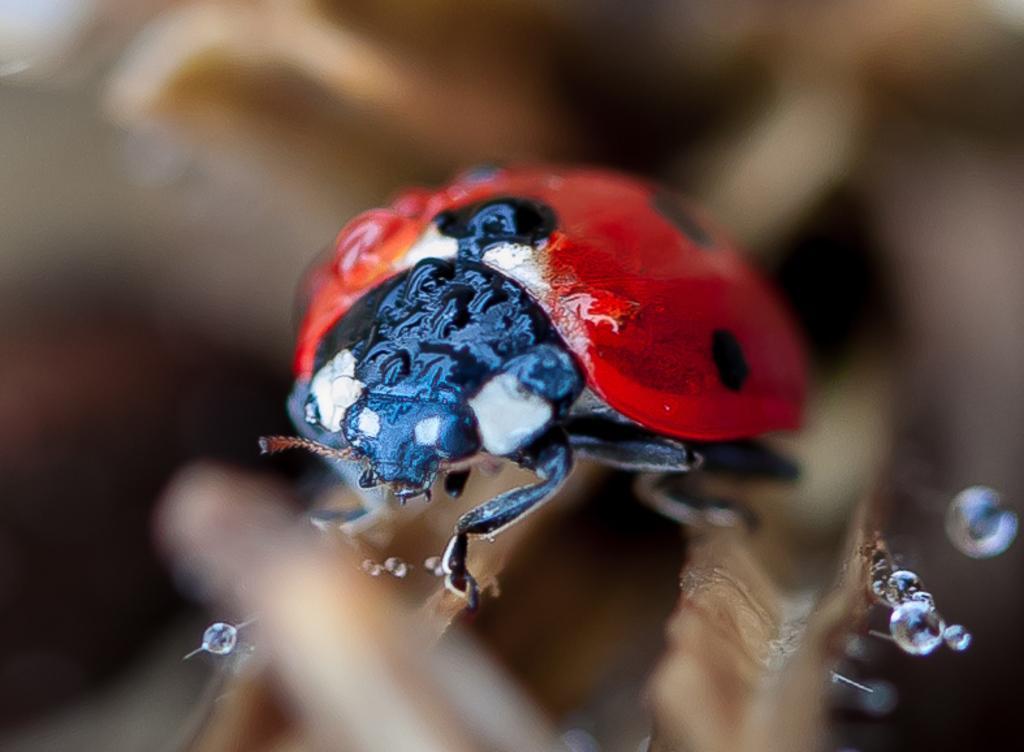Please provide a concise description of this image. This image is taken outdoors. In this image the background is a little blurred. In the middle of the image there is a bug on the stem and there are a few water droplets. The bug is red and black in colors. 